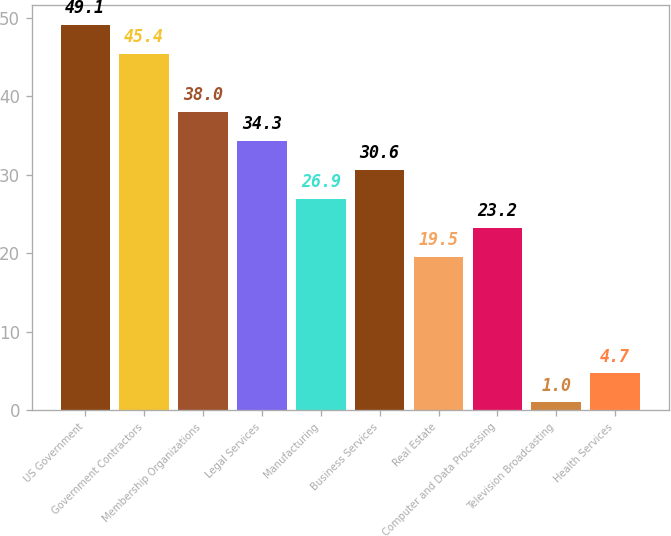Convert chart to OTSL. <chart><loc_0><loc_0><loc_500><loc_500><bar_chart><fcel>US Government<fcel>Government Contractors<fcel>Membership Organizations<fcel>Legal Services<fcel>Manufacturing<fcel>Business Services<fcel>Real Estate<fcel>Computer and Data Processing<fcel>Television Broadcasting<fcel>Health Services<nl><fcel>49.1<fcel>45.4<fcel>38<fcel>34.3<fcel>26.9<fcel>30.6<fcel>19.5<fcel>23.2<fcel>1<fcel>4.7<nl></chart> 